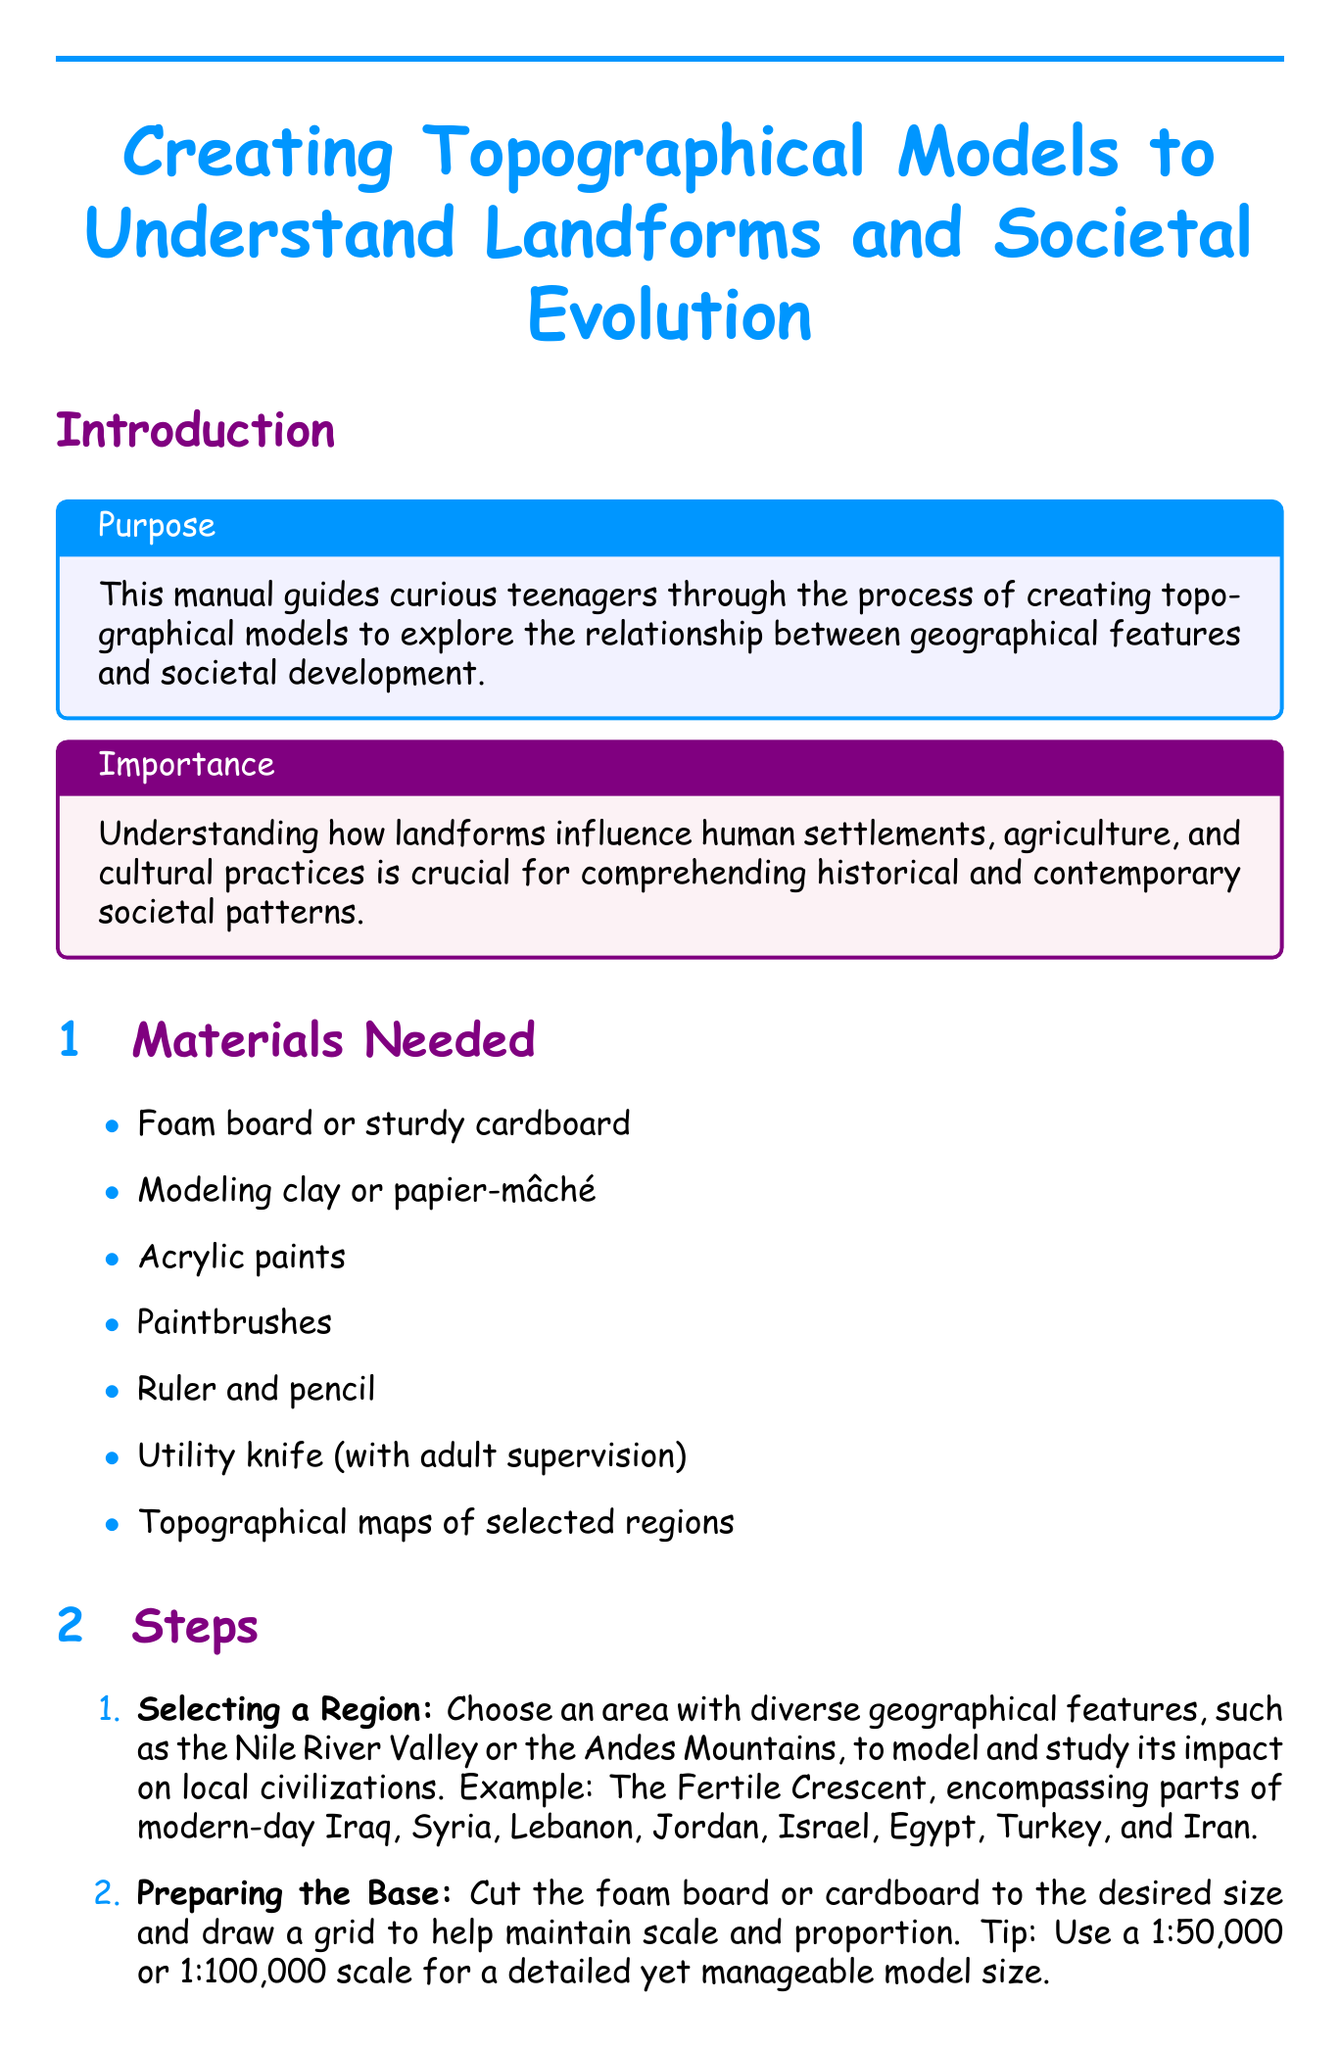What is the title of the manual? The title is presented at the beginning of the document and states the main focus.
Answer: Creating Topographical Models to Understand Landforms and Societal Evolution How many case studies are included in the document? The document lists the exact number of case studies in the case study section.
Answer: 2 What material is suggested for sculpting landforms? The materials needed section provides a specific recommendation for this purpose.
Answer: Modeling clay or papier-mâché Which color represents forests in the painting section? The color guide in the painting section details the specific colors for different terrains.
Answer: Dark green What geographical feature is examined for the Inca Empire case study? The case study description specifies the terrain that was adapted by the Inca Empire.
Answer: Andes How does the document suggest maintaining scale in the base preparation step? The preparation step provides a specific scaling technique to ensure accuracy.
Answer: Use a 1:50,000 or 1:100,000 scale What two rivers are mentioned in the Mesopotamia case study? The document explicitly names the rivers in the context of the case study about Mesopotamia.
Answer: Tigris and Euphrates What is one example of a location to mark in the model? The adding human elements section includes specific locations as examples to illustrate human geography.
Answer: Machu Picchu 